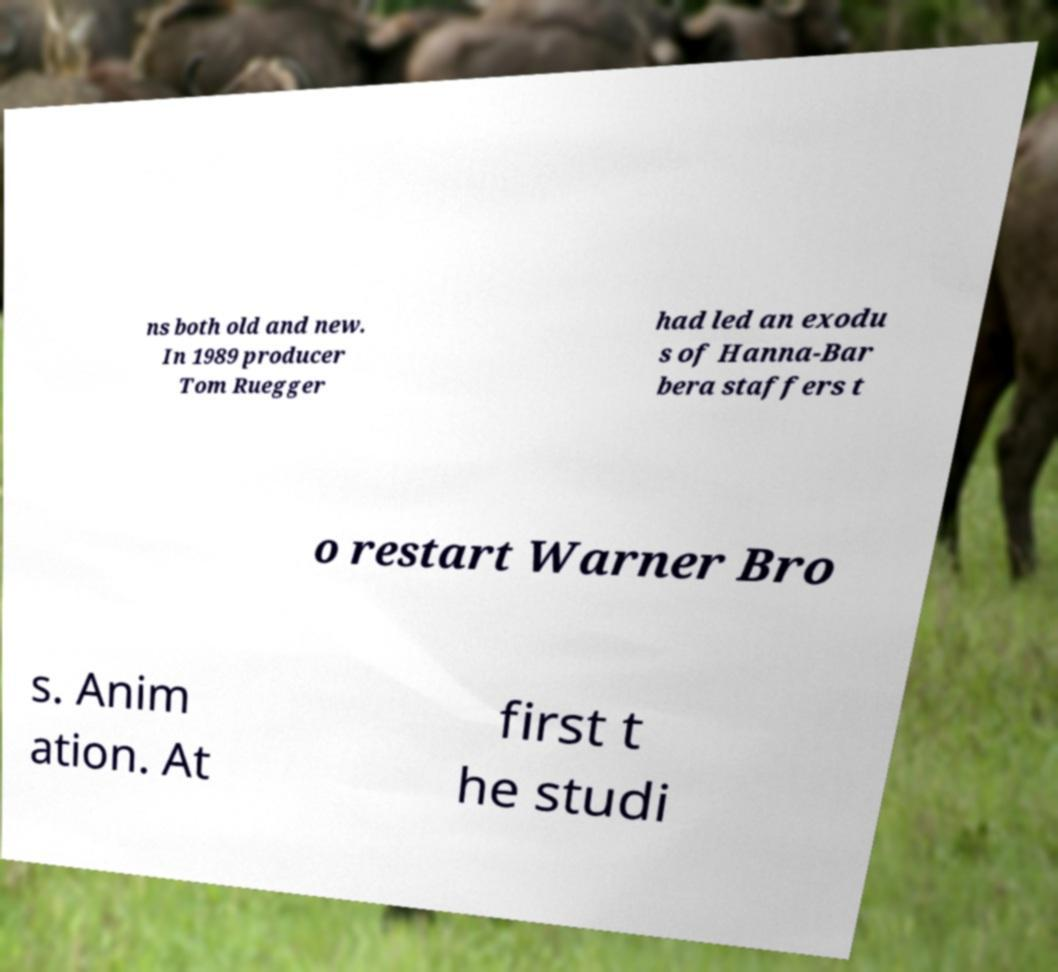Please read and relay the text visible in this image. What does it say? ns both old and new. In 1989 producer Tom Ruegger had led an exodu s of Hanna-Bar bera staffers t o restart Warner Bro s. Anim ation. At first t he studi 